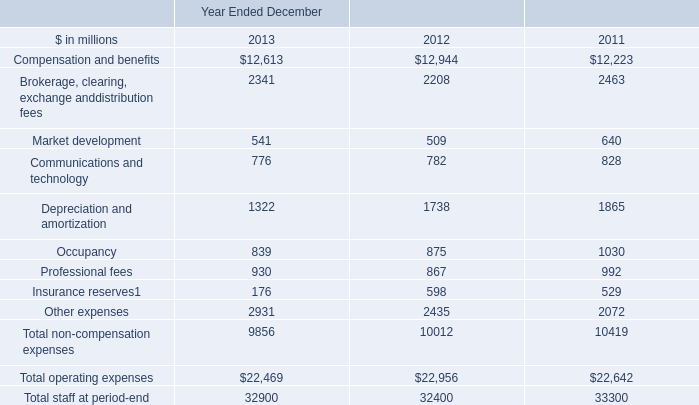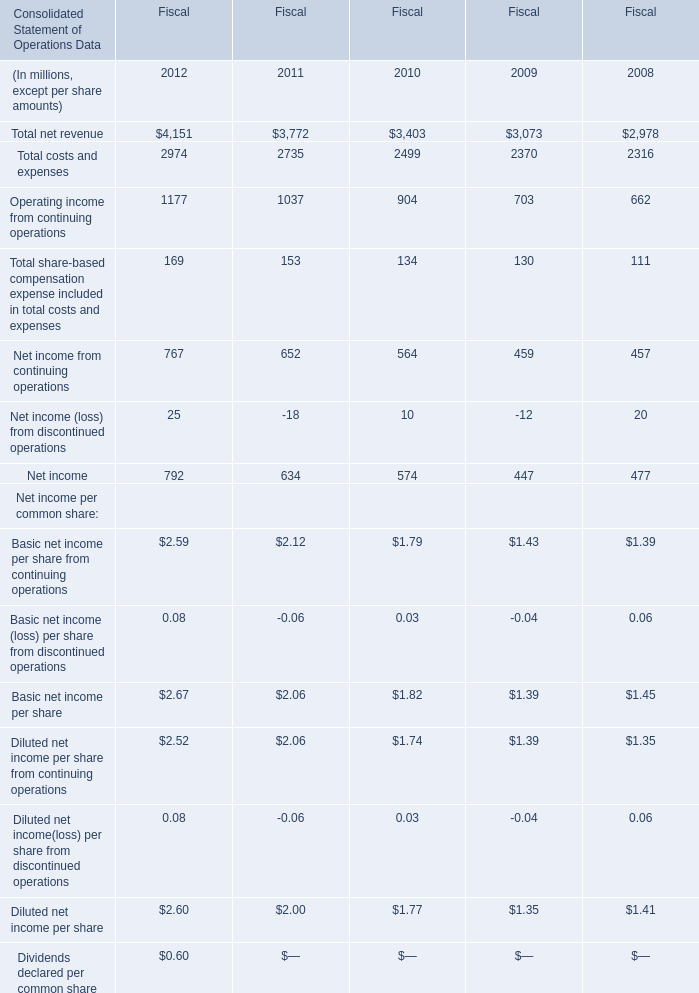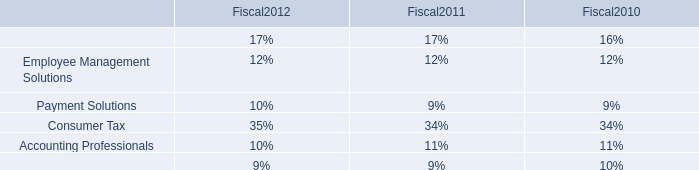Which year is Total costs and expenses the most? 
Answer: 2012. What is the growing rate of operating income from continuing operations in the year with the most total costs and expenses? (in %) 
Computations: ((1177 - 1037) / 1037)
Answer: 0.135. What's the average of Depreciation and amortization of Year Ended December 2013, and Operating income from continuing operations of Fiscal 2012 ? 
Computations: ((1322.0 + 1177.0) / 2)
Answer: 1249.5. 